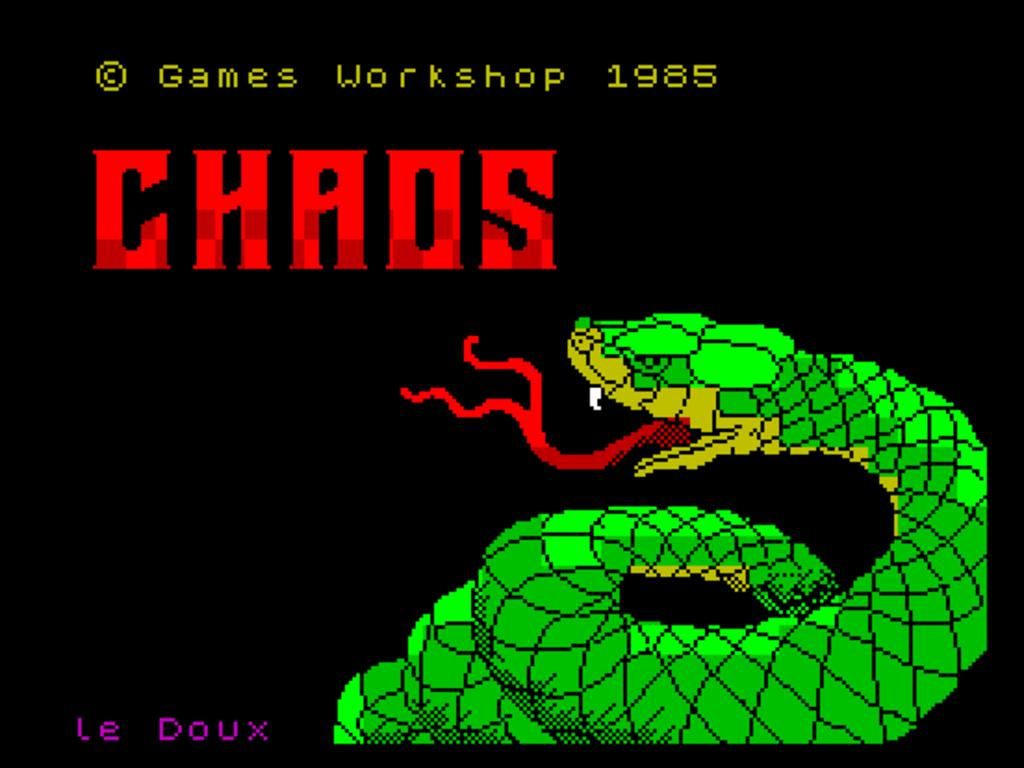What type of image is at the bottom of the picture? There is a cartoon picture of a snake at the bottom of the image. What can be found at the top of the image? There is text at the top of the image. What type of work is the snake doing in the image? There is no indication of the snake performing any work in the image, as it is a cartoon picture. What type of tongue does the snake have in the image? The image is a cartoon, and cartoon snakes typically do not have realistic tongues. 